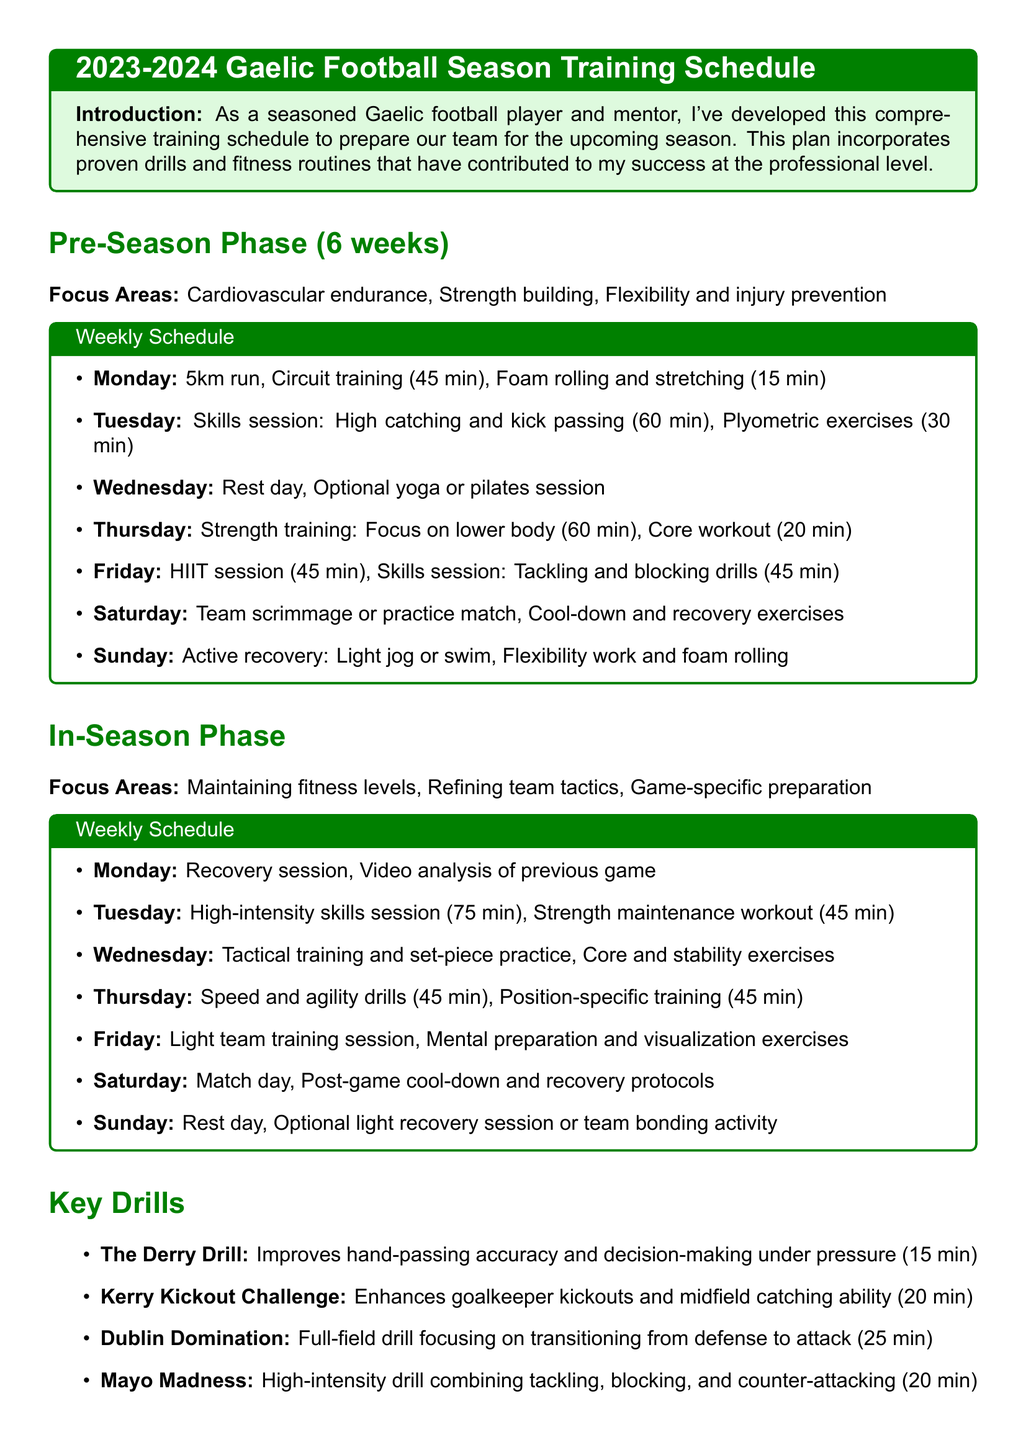What is the duration of the pre-season phase? The duration of the pre-season phase is specified in the document.
Answer: 6 weeks What activity is scheduled for Monday during the pre-season? The document outlines the activities scheduled for each day during the pre-season phase.
Answer: 5km run What is included in the in-season focus areas? The in-season focus areas are mentioned in a list within the document.
Answer: Maintaining fitness levels How long is the "Dublin Domination" drill? The duration of the "Dublin Domination" drill is provided in the key drills section of the document.
Answer: 25 minutes What type of exercises are suggested on Sundays during the pre-season phase? The document details the activities planned for each day, including Sundays in the pre-season phase.
Answer: Active recovery What is the purpose of the "Kerry Kickout Challenge"? The document describes the objective of each key drill, including this one.
Answer: Enhances goalkeeper kickouts How long is the "All-Ireland Intervals" fitness routine? The fitness routines section includes the duration of each routine.
Answer: 35 minutes What is the key to success mentioned in the conclusion? The conclusion section highlights the essential factors for success as stated in the document.
Answer: Teamwork 